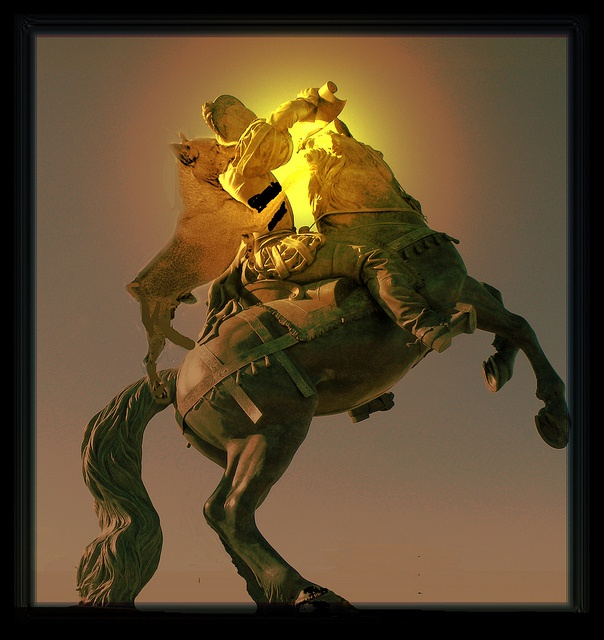Describe the objects in this image and their specific colors. I can see horse in black, olive, brown, and gray tones and dog in black, brown, and maroon tones in this image. 